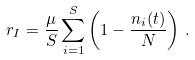<formula> <loc_0><loc_0><loc_500><loc_500>r _ { I } = \frac { \mu } { S } \sum _ { i = 1 } ^ { S } \left ( 1 - \frac { n _ { i } ( t ) } { N } \right ) \, .</formula> 